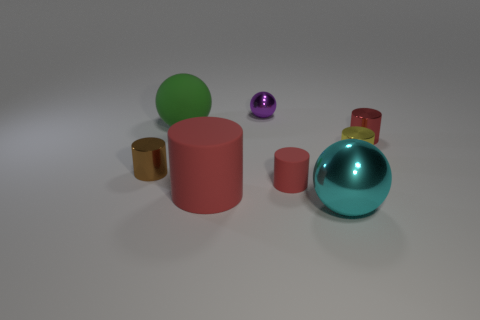There is a small cylinder that is to the right of the green sphere and left of the small yellow metal thing; what material is it?
Ensure brevity in your answer.  Rubber. Do the purple metallic object and the shiny thing that is in front of the brown metallic cylinder have the same shape?
Offer a very short reply. Yes. What number of other objects are the same size as the brown thing?
Provide a succinct answer. 4. Is the number of big green spheres greater than the number of tiny cyan rubber things?
Ensure brevity in your answer.  Yes. How many spheres are both behind the big red matte cylinder and to the right of the green rubber object?
Give a very brief answer. 1. There is a big object that is behind the small cylinder that is left of the tiny red thing on the left side of the cyan metal thing; what is its shape?
Offer a terse response. Sphere. Are there any other things that are the same shape as the small purple thing?
Give a very brief answer. Yes. How many blocks are big gray metallic things or yellow things?
Keep it short and to the point. 0. Does the shiny ball that is left of the cyan metallic object have the same color as the large matte ball?
Provide a succinct answer. No. There is a large ball in front of the big green rubber thing that is behind the tiny cylinder that is to the left of the big green rubber ball; what is its material?
Offer a terse response. Metal. 